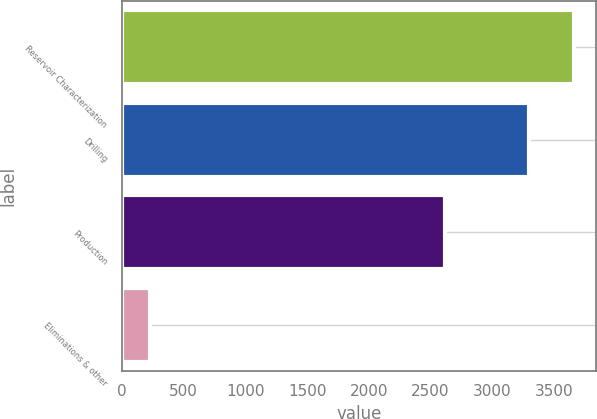<chart> <loc_0><loc_0><loc_500><loc_500><bar_chart><fcel>Reservoir Characterization<fcel>Drilling<fcel>Production<fcel>Eliminations & other<nl><fcel>3660<fcel>3293<fcel>2619<fcel>228<nl></chart> 